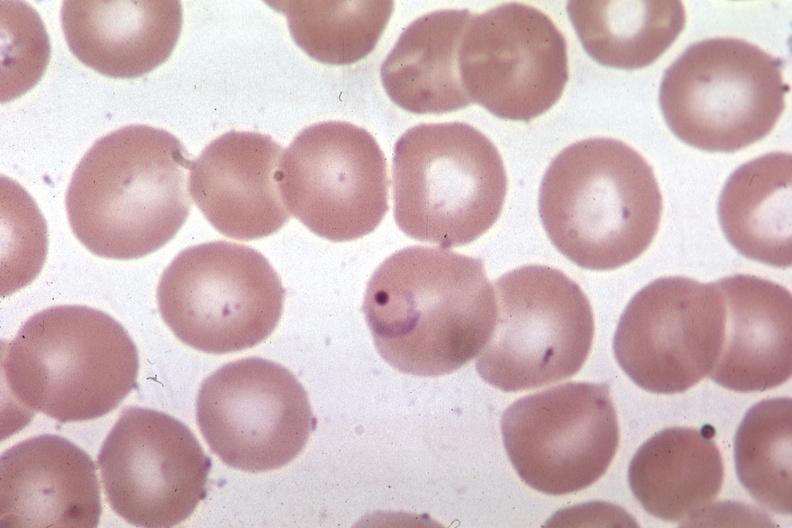s malaria plasmodium vivax present?
Answer the question using a single word or phrase. Yes 